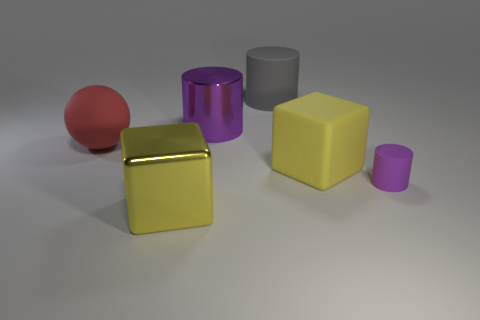Subtract all gray matte cylinders. How many cylinders are left? 2 Subtract all cyan spheres. How many purple cylinders are left? 2 Subtract 1 cylinders. How many cylinders are left? 2 Add 4 tiny green things. How many objects exist? 10 Subtract all cubes. How many objects are left? 4 Add 3 blue shiny cylinders. How many blue shiny cylinders exist? 3 Subtract 0 gray spheres. How many objects are left? 6 Subtract all green cylinders. Subtract all brown cubes. How many cylinders are left? 3 Subtract all large gray cylinders. Subtract all gray matte cylinders. How many objects are left? 4 Add 6 large purple things. How many large purple things are left? 7 